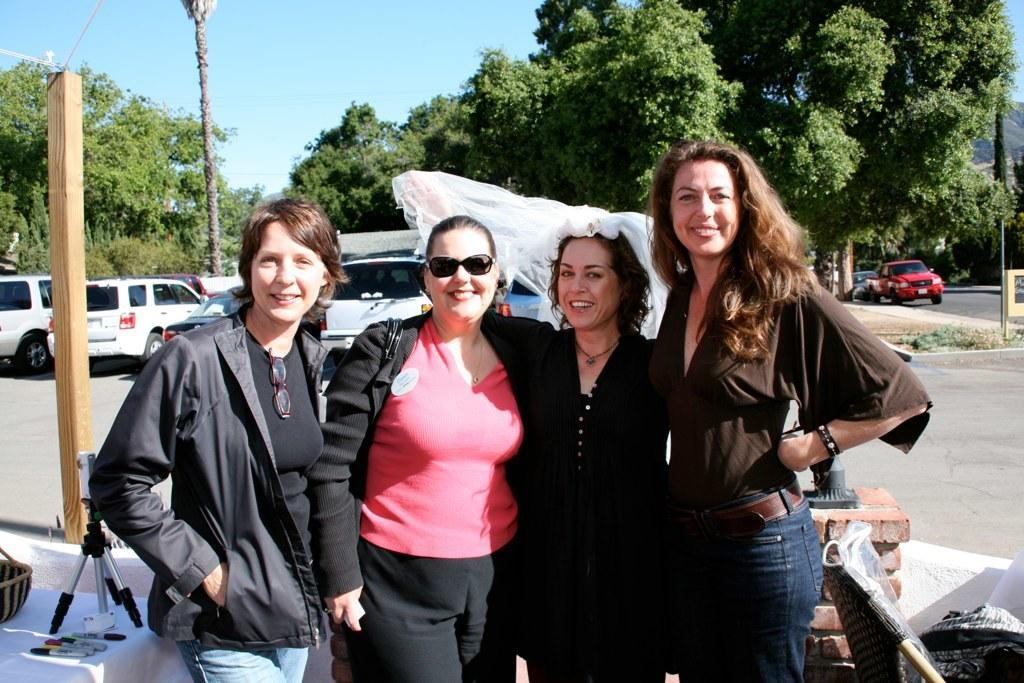How many people are present in the image? There are four people in the image. What is the facial expression of the people in the image? The people are smiling. What can be seen in the background of the image? There are vehicles, trees, the sky, and some objects in the background of the image. How does the goose increase the speed of the vehicles in the image? There is no goose present in the image, and therefore it cannot affect the speed of any vehicles. 